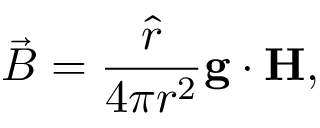Convert formula to latex. <formula><loc_0><loc_0><loc_500><loc_500>\vec { B } = { \frac { \hat { r } } { 4 \pi r ^ { 2 } } } { g \cdot H } ,</formula> 